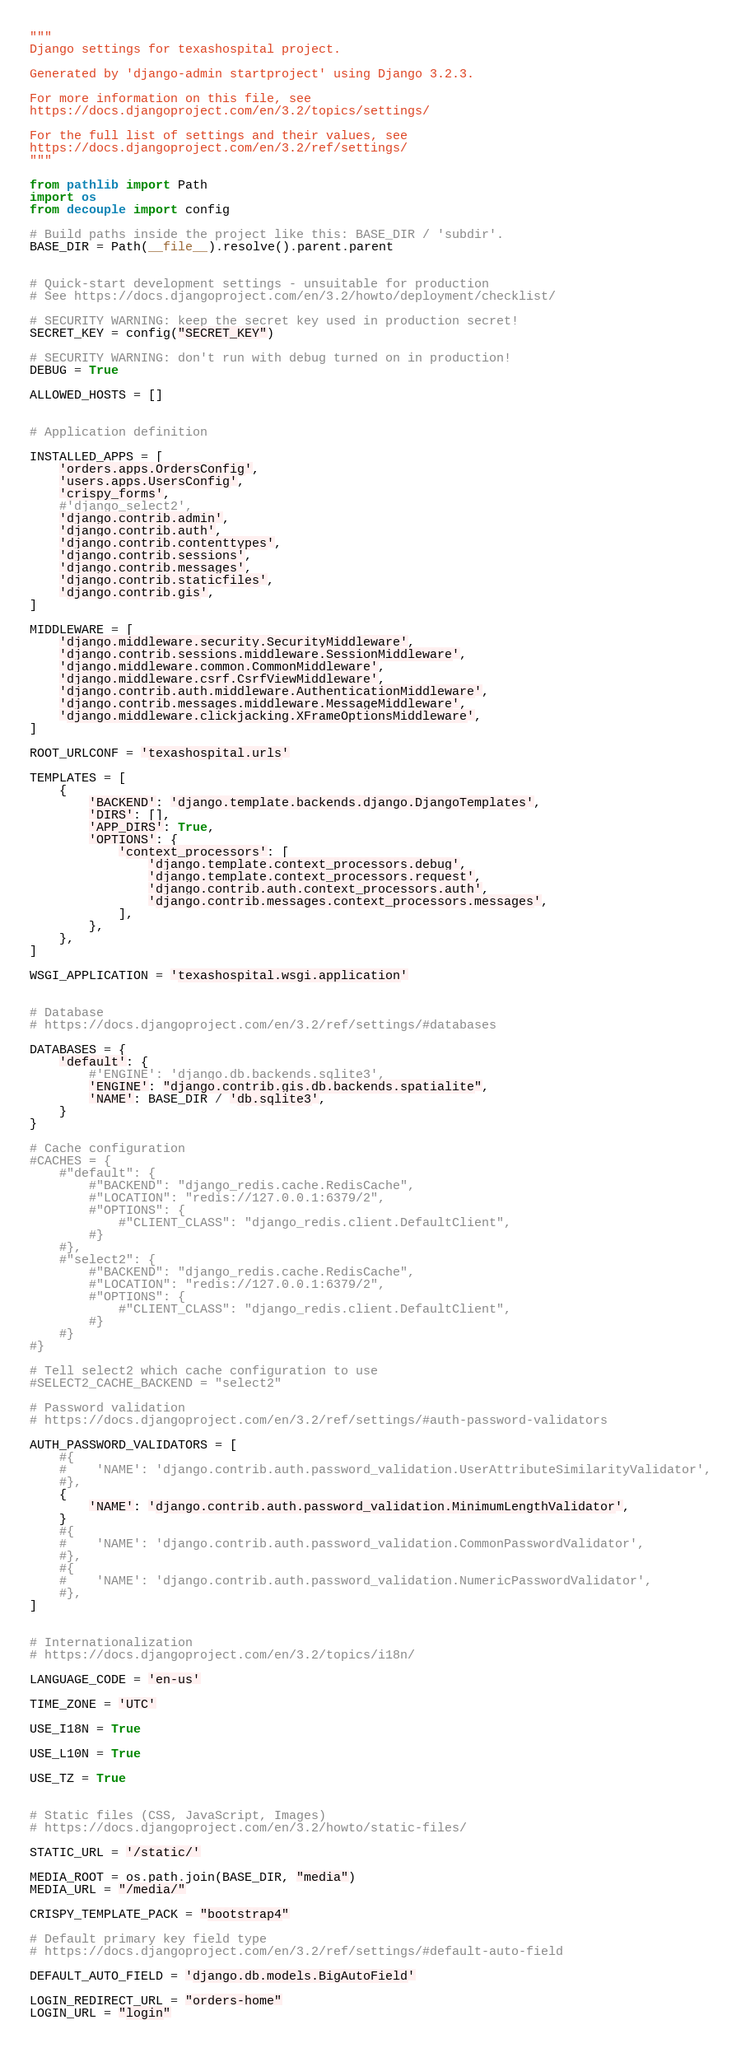Convert code to text. <code><loc_0><loc_0><loc_500><loc_500><_Python_>"""
Django settings for texashospital project.

Generated by 'django-admin startproject' using Django 3.2.3.

For more information on this file, see
https://docs.djangoproject.com/en/3.2/topics/settings/

For the full list of settings and their values, see
https://docs.djangoproject.com/en/3.2/ref/settings/
"""

from pathlib import Path
import os
from decouple import config

# Build paths inside the project like this: BASE_DIR / 'subdir'.
BASE_DIR = Path(__file__).resolve().parent.parent


# Quick-start development settings - unsuitable for production
# See https://docs.djangoproject.com/en/3.2/howto/deployment/checklist/

# SECURITY WARNING: keep the secret key used in production secret!
SECRET_KEY = config("SECRET_KEY")

# SECURITY WARNING: don't run with debug turned on in production!
DEBUG = True

ALLOWED_HOSTS = []


# Application definition

INSTALLED_APPS = [
    'orders.apps.OrdersConfig',
    'users.apps.UsersConfig',
    'crispy_forms',
    #'django_select2',
    'django.contrib.admin',
    'django.contrib.auth',
    'django.contrib.contenttypes',
    'django.contrib.sessions',
    'django.contrib.messages',
    'django.contrib.staticfiles',
    'django.contrib.gis',
]

MIDDLEWARE = [
    'django.middleware.security.SecurityMiddleware',
    'django.contrib.sessions.middleware.SessionMiddleware',
    'django.middleware.common.CommonMiddleware',
    'django.middleware.csrf.CsrfViewMiddleware',
    'django.contrib.auth.middleware.AuthenticationMiddleware',
    'django.contrib.messages.middleware.MessageMiddleware',
    'django.middleware.clickjacking.XFrameOptionsMiddleware',
]

ROOT_URLCONF = 'texashospital.urls'

TEMPLATES = [
    {
        'BACKEND': 'django.template.backends.django.DjangoTemplates',
        'DIRS': [],
        'APP_DIRS': True,
        'OPTIONS': {
            'context_processors': [
                'django.template.context_processors.debug',
                'django.template.context_processors.request',
                'django.contrib.auth.context_processors.auth',
                'django.contrib.messages.context_processors.messages',
            ],
        },
    },
]

WSGI_APPLICATION = 'texashospital.wsgi.application'


# Database
# https://docs.djangoproject.com/en/3.2/ref/settings/#databases

DATABASES = {
    'default': {
        #'ENGINE': 'django.db.backends.sqlite3',
        'ENGINE': "django.contrib.gis.db.backends.spatialite",
        'NAME': BASE_DIR / 'db.sqlite3',
    }
}

# Cache configuration
#CACHES = {
    #"default": {
        #"BACKEND": "django_redis.cache.RedisCache",
        #"LOCATION": "redis://127.0.0.1:6379/2",
        #"OPTIONS": {
            #"CLIENT_CLASS": "django_redis.client.DefaultClient",
        #}
    #},
    #"select2": {
        #"BACKEND": "django_redis.cache.RedisCache",
        #"LOCATION": "redis://127.0.0.1:6379/2",
        #"OPTIONS": {
            #"CLIENT_CLASS": "django_redis.client.DefaultClient",
        #}
    #}
#}

# Tell select2 which cache configuration to use
#SELECT2_CACHE_BACKEND = "select2"

# Password validation
# https://docs.djangoproject.com/en/3.2/ref/settings/#auth-password-validators

AUTH_PASSWORD_VALIDATORS = [
    #{
    #    'NAME': 'django.contrib.auth.password_validation.UserAttributeSimilarityValidator',
    #},
    {
        'NAME': 'django.contrib.auth.password_validation.MinimumLengthValidator',
    }
    #{
    #    'NAME': 'django.contrib.auth.password_validation.CommonPasswordValidator',
    #},
    #{
    #    'NAME': 'django.contrib.auth.password_validation.NumericPasswordValidator',
    #},
]


# Internationalization
# https://docs.djangoproject.com/en/3.2/topics/i18n/

LANGUAGE_CODE = 'en-us'

TIME_ZONE = 'UTC'

USE_I18N = True

USE_L10N = True

USE_TZ = True


# Static files (CSS, JavaScript, Images)
# https://docs.djangoproject.com/en/3.2/howto/static-files/

STATIC_URL = '/static/'

MEDIA_ROOT = os.path.join(BASE_DIR, "media")
MEDIA_URL = "/media/"

CRISPY_TEMPLATE_PACK = "bootstrap4"

# Default primary key field type
# https://docs.djangoproject.com/en/3.2/ref/settings/#default-auto-field

DEFAULT_AUTO_FIELD = 'django.db.models.BigAutoField'

LOGIN_REDIRECT_URL = "orders-home"
LOGIN_URL = "login"

</code> 